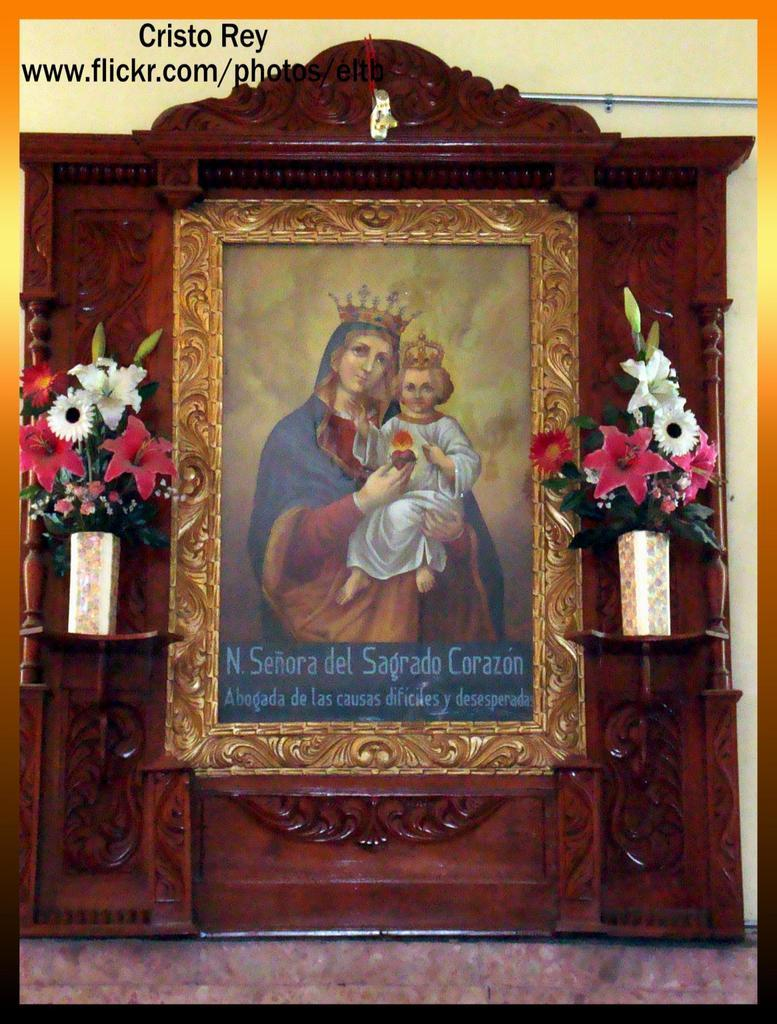<image>
Create a compact narrative representing the image presented. a portrait from www.flickr.com titled 'cristo rey' at the top 